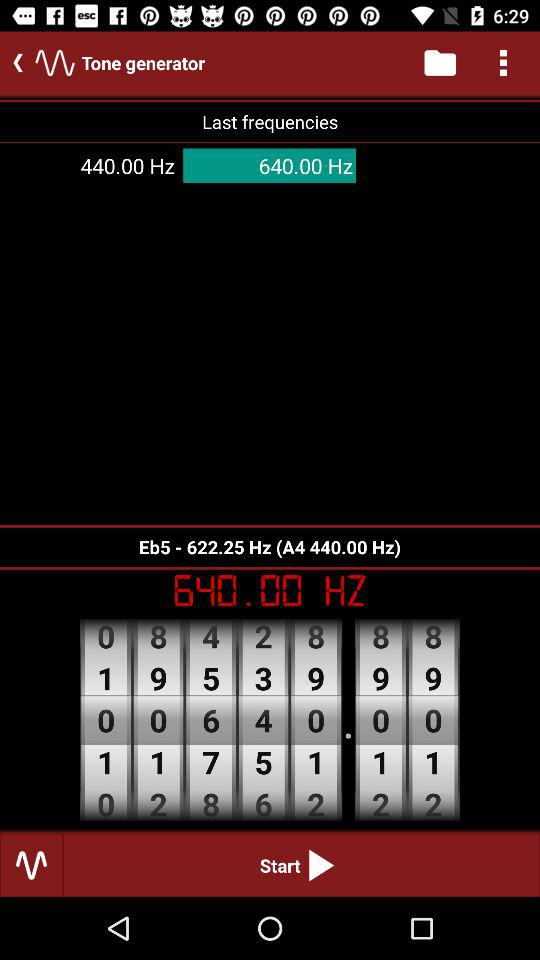What is the application name? The application name is "Tone generator". 